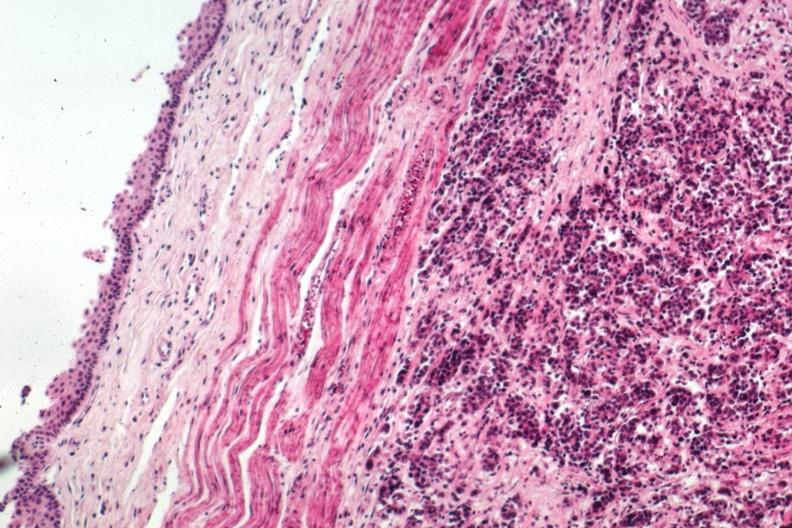where is this from?
Answer the question using a single word or phrase. Gastrointestinal system 